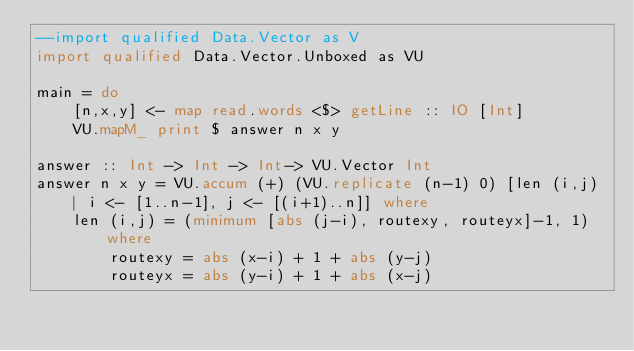<code> <loc_0><loc_0><loc_500><loc_500><_Haskell_>--import qualified Data.Vector as V
import qualified Data.Vector.Unboxed as VU

main = do
    [n,x,y] <- map read.words <$> getLine :: IO [Int]
    VU.mapM_ print $ answer n x y

answer :: Int -> Int -> Int-> VU.Vector Int
answer n x y = VU.accum (+) (VU.replicate (n-1) 0) [len (i,j) | i <- [1..n-1], j <- [(i+1)..n]] where
    len (i,j) = (minimum [abs (j-i), routexy, routeyx]-1, 1) where
        routexy = abs (x-i) + 1 + abs (y-j)
        routeyx = abs (y-i) + 1 + abs (x-j)</code> 